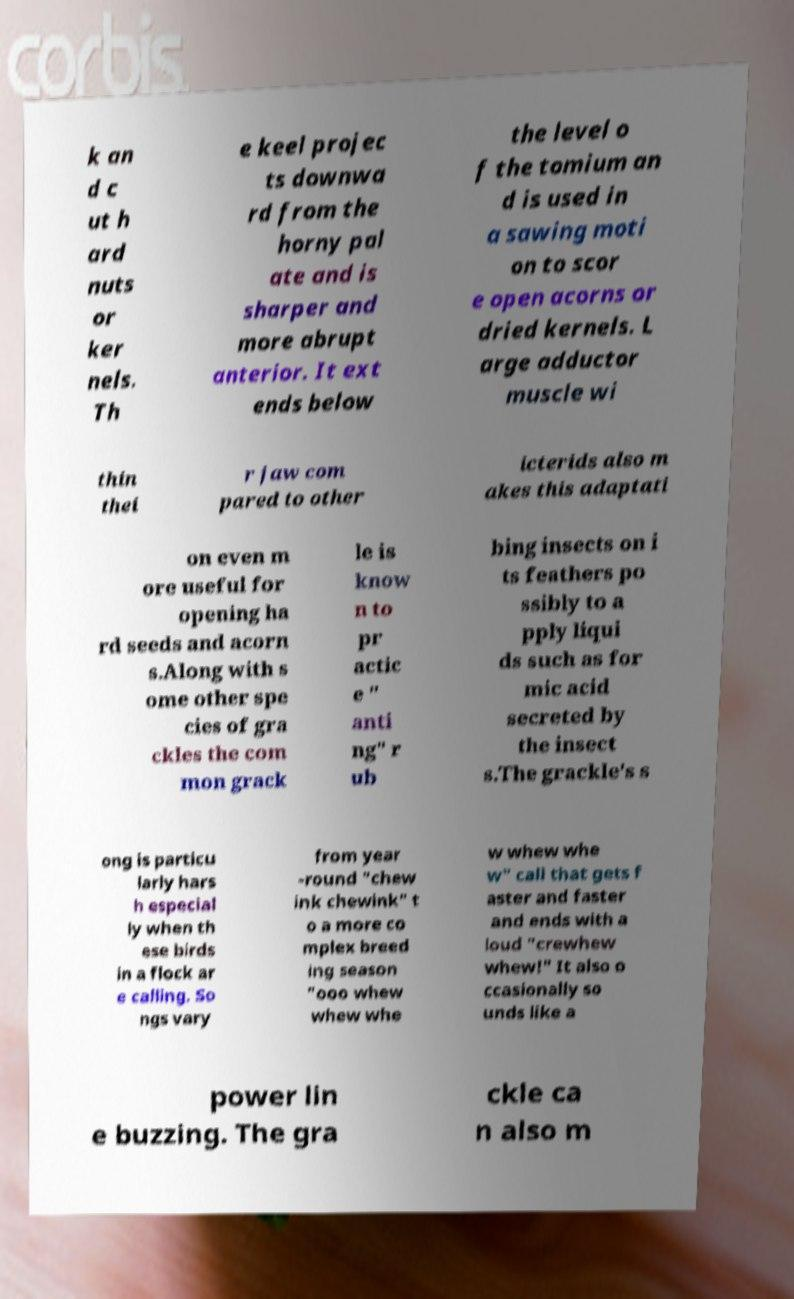Please read and relay the text visible in this image. What does it say? k an d c ut h ard nuts or ker nels. Th e keel projec ts downwa rd from the horny pal ate and is sharper and more abrupt anterior. It ext ends below the level o f the tomium an d is used in a sawing moti on to scor e open acorns or dried kernels. L arge adductor muscle wi thin thei r jaw com pared to other icterids also m akes this adaptati on even m ore useful for opening ha rd seeds and acorn s.Along with s ome other spe cies of gra ckles the com mon grack le is know n to pr actic e " anti ng" r ub bing insects on i ts feathers po ssibly to a pply liqui ds such as for mic acid secreted by the insect s.The grackle's s ong is particu larly hars h especial ly when th ese birds in a flock ar e calling. So ngs vary from year -round "chew ink chewink" t o a more co mplex breed ing season "ooo whew whew whe w whew whe w" call that gets f aster and faster and ends with a loud "crewhew whew!" It also o ccasionally so unds like a power lin e buzzing. The gra ckle ca n also m 